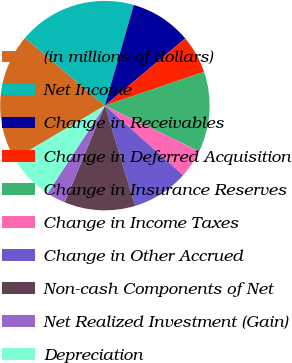Convert chart. <chart><loc_0><loc_0><loc_500><loc_500><pie_chart><fcel>(in millions of dollars)<fcel>Net Income<fcel>Change in Receivables<fcel>Change in Deferred Acquisition<fcel>Change in Insurance Reserves<fcel>Change in Income Taxes<fcel>Change in Other Accrued<fcel>Non-cash Components of Net<fcel>Net Realized Investment (Gain)<fcel>Depreciation<nl><fcel>19.69%<fcel>18.24%<fcel>9.49%<fcel>5.85%<fcel>12.41%<fcel>4.39%<fcel>8.76%<fcel>10.95%<fcel>2.93%<fcel>7.3%<nl></chart> 